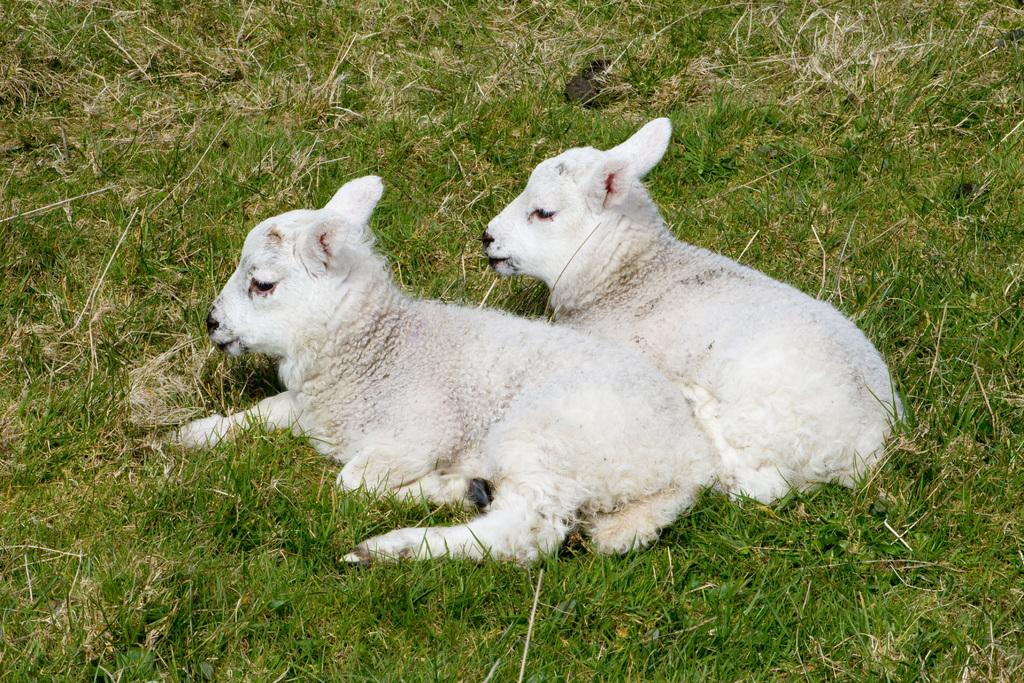What type of living organisms can be seen in the image? There are animals in the image. What is the animals' position in relation to the grass? The animals are sitting on the grass. What color are the animals in the image? The animals are white in color. What type of vegetation is visible in the image? There is grass visible in the image. How do the animals measure the height of the tree in the image? There is no tree present in the image, so the animals cannot measure its height. 